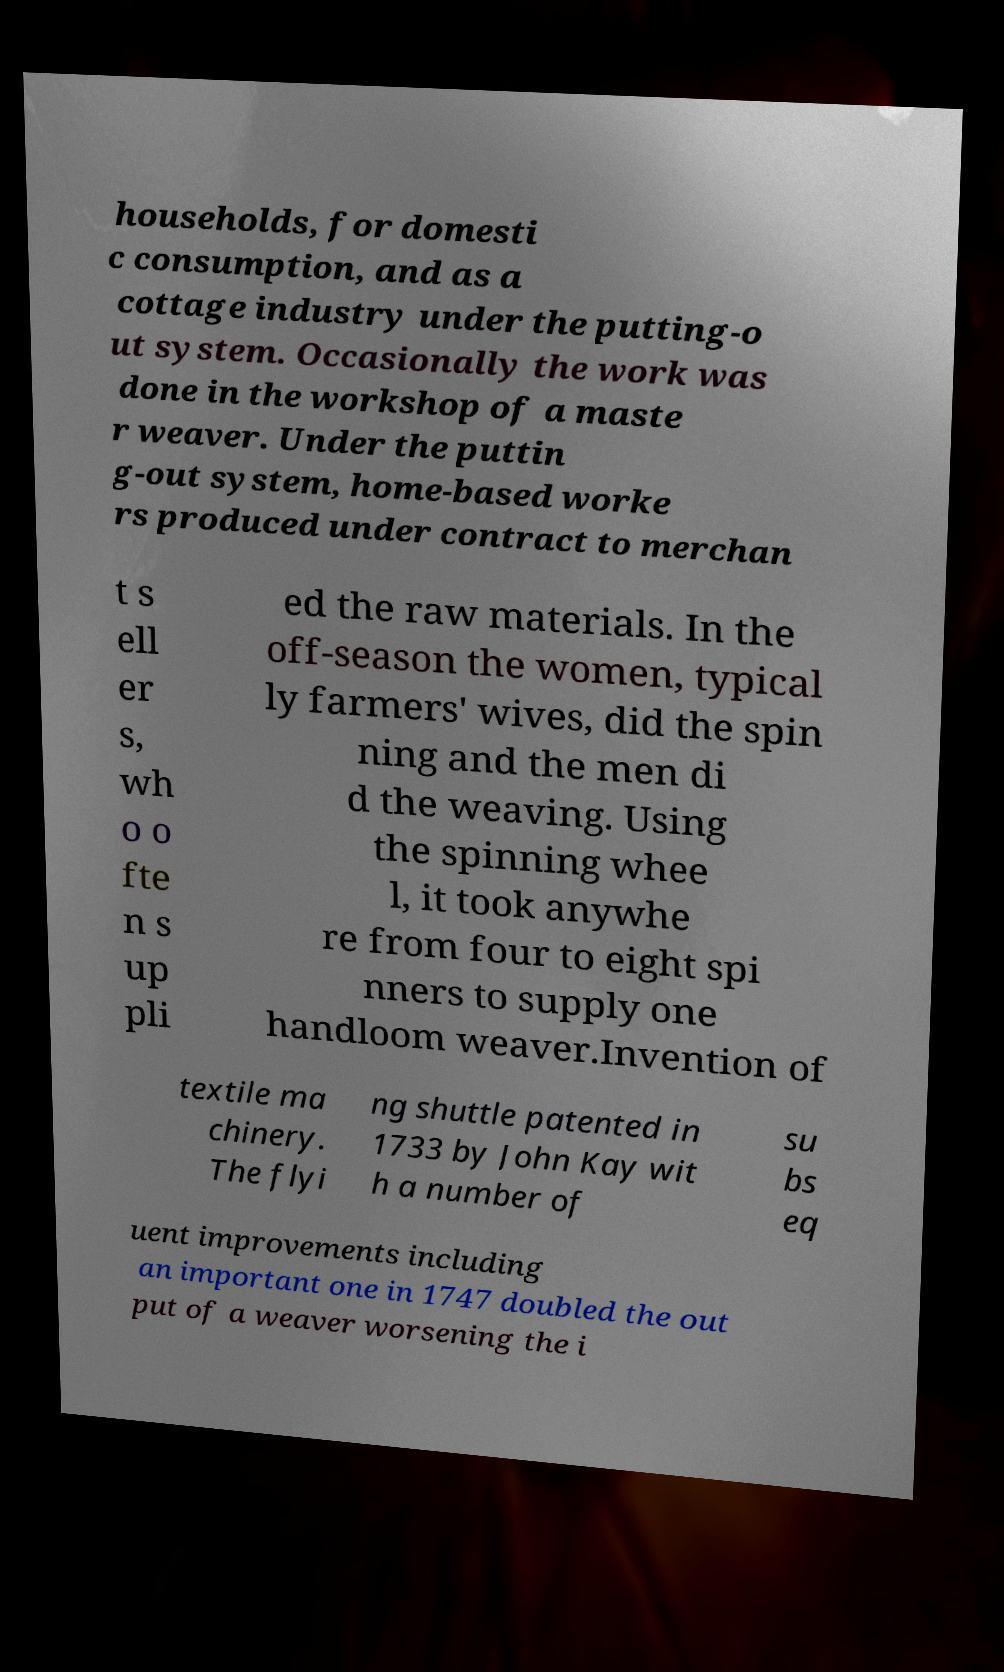For documentation purposes, I need the text within this image transcribed. Could you provide that? households, for domesti c consumption, and as a cottage industry under the putting-o ut system. Occasionally the work was done in the workshop of a maste r weaver. Under the puttin g-out system, home-based worke rs produced under contract to merchan t s ell er s, wh o o fte n s up pli ed the raw materials. In the off-season the women, typical ly farmers' wives, did the spin ning and the men di d the weaving. Using the spinning whee l, it took anywhe re from four to eight spi nners to supply one handloom weaver.Invention of textile ma chinery. The flyi ng shuttle patented in 1733 by John Kay wit h a number of su bs eq uent improvements including an important one in 1747 doubled the out put of a weaver worsening the i 